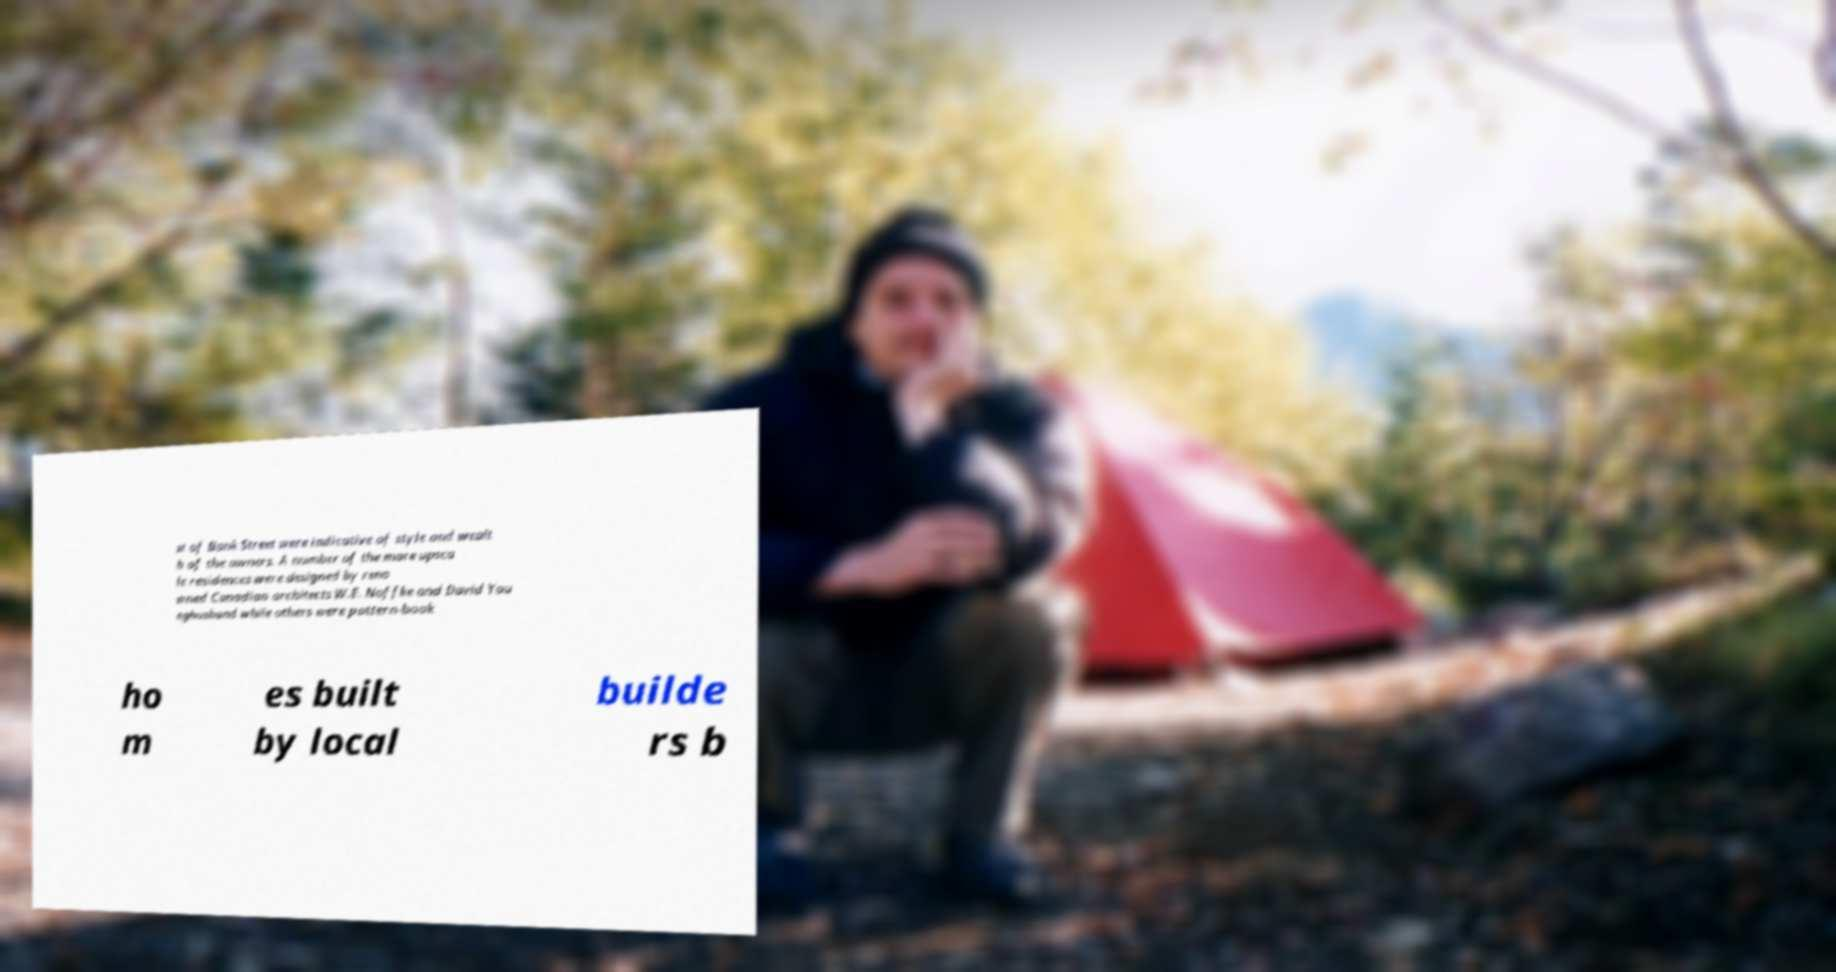For documentation purposes, I need the text within this image transcribed. Could you provide that? st of Bank Street were indicative of style and wealt h of the owners. A number of the more upsca le residences were designed by reno wned Canadian architects W.E. Noffke and David You nghusband while others were pattern-book ho m es built by local builde rs b 